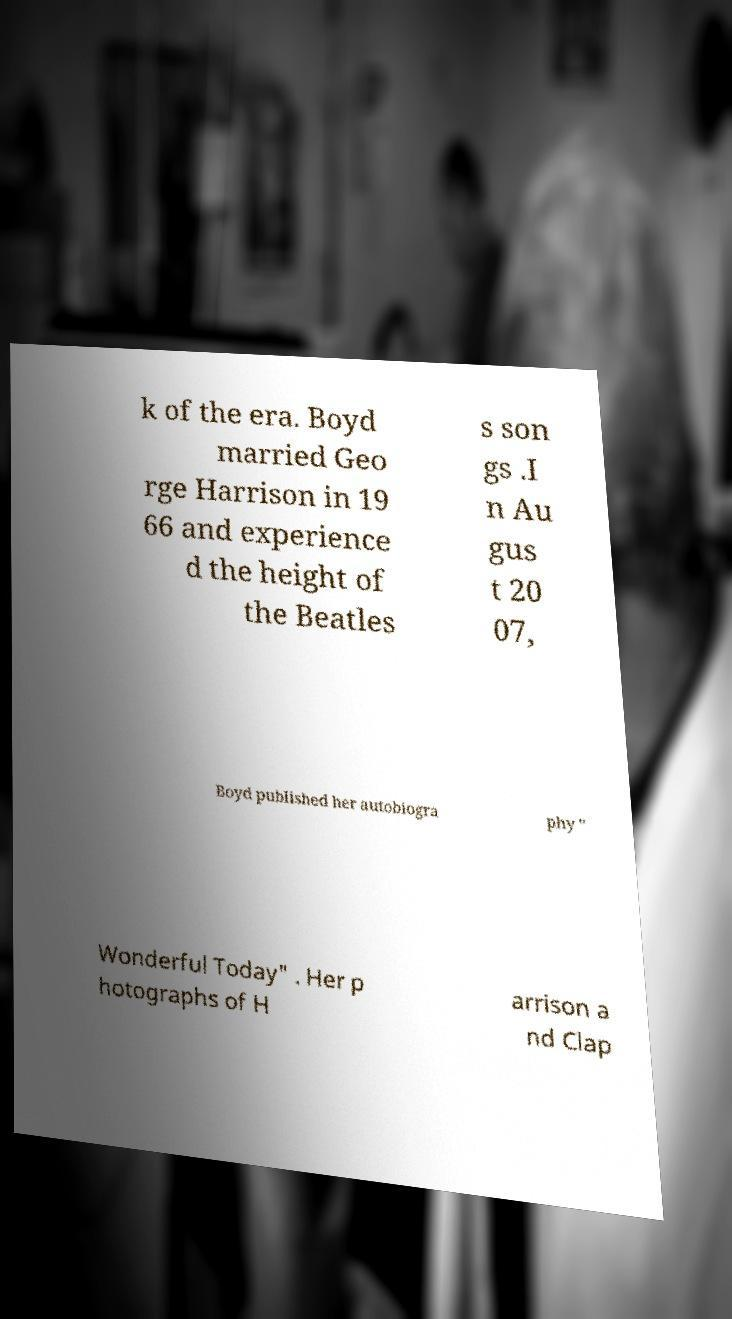I need the written content from this picture converted into text. Can you do that? k of the era. Boyd married Geo rge Harrison in 19 66 and experience d the height of the Beatles s son gs .I n Au gus t 20 07, Boyd published her autobiogra phy " Wonderful Today" . Her p hotographs of H arrison a nd Clap 